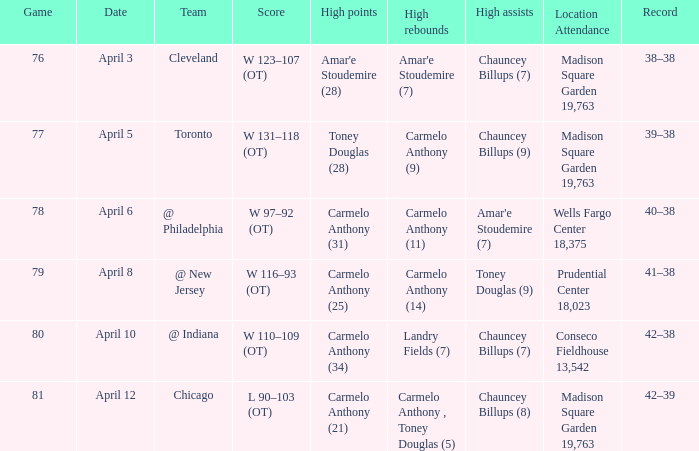List the leading assists in madison square garden with 19,763 seats and a 39-38 win-loss record. Chauncey Billups (9). 